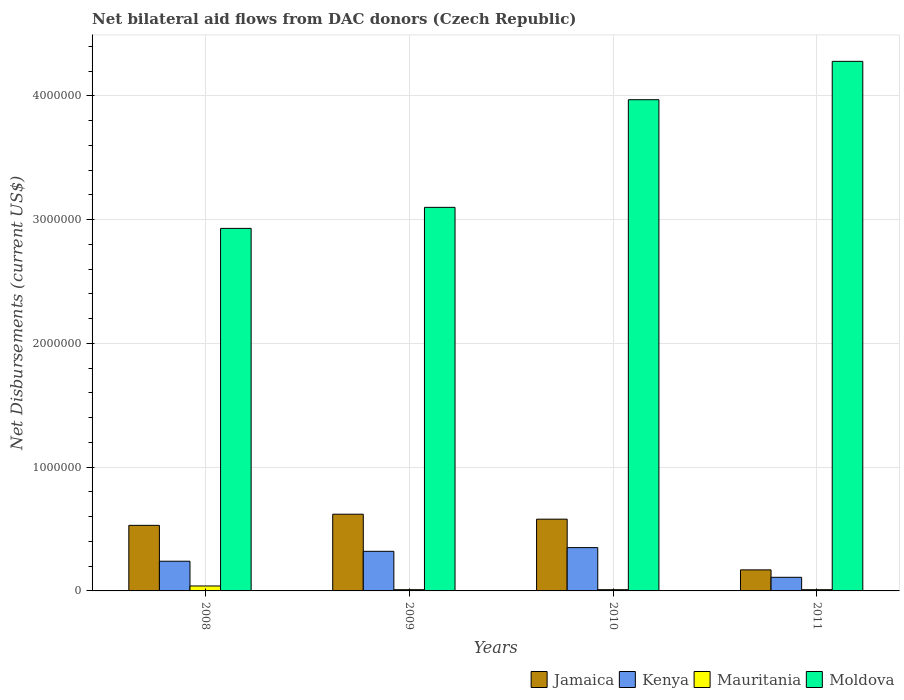How many groups of bars are there?
Provide a short and direct response. 4. Are the number of bars on each tick of the X-axis equal?
Your answer should be very brief. Yes. How many bars are there on the 2nd tick from the right?
Your answer should be compact. 4. What is the label of the 3rd group of bars from the left?
Ensure brevity in your answer.  2010. In how many cases, is the number of bars for a given year not equal to the number of legend labels?
Give a very brief answer. 0. What is the net bilateral aid flows in Moldova in 2009?
Ensure brevity in your answer.  3.10e+06. Across all years, what is the maximum net bilateral aid flows in Jamaica?
Make the answer very short. 6.20e+05. Across all years, what is the minimum net bilateral aid flows in Moldova?
Provide a succinct answer. 2.93e+06. What is the difference between the net bilateral aid flows in Kenya in 2009 and that in 2010?
Ensure brevity in your answer.  -3.00e+04. What is the difference between the net bilateral aid flows in Mauritania in 2011 and the net bilateral aid flows in Jamaica in 2010?
Keep it short and to the point. -5.70e+05. What is the average net bilateral aid flows in Moldova per year?
Your answer should be very brief. 3.57e+06. In the year 2008, what is the difference between the net bilateral aid flows in Mauritania and net bilateral aid flows in Moldova?
Your answer should be very brief. -2.89e+06. What is the ratio of the net bilateral aid flows in Kenya in 2010 to that in 2011?
Your response must be concise. 3.18. Is the difference between the net bilateral aid flows in Mauritania in 2008 and 2009 greater than the difference between the net bilateral aid flows in Moldova in 2008 and 2009?
Offer a very short reply. Yes. What is the difference between the highest and the second highest net bilateral aid flows in Mauritania?
Your answer should be very brief. 3.00e+04. Is it the case that in every year, the sum of the net bilateral aid flows in Kenya and net bilateral aid flows in Moldova is greater than the sum of net bilateral aid flows in Mauritania and net bilateral aid flows in Jamaica?
Your answer should be compact. No. What does the 4th bar from the left in 2011 represents?
Offer a terse response. Moldova. What does the 3rd bar from the right in 2011 represents?
Ensure brevity in your answer.  Kenya. Are all the bars in the graph horizontal?
Offer a very short reply. No. Does the graph contain grids?
Provide a short and direct response. Yes. Where does the legend appear in the graph?
Make the answer very short. Bottom right. How are the legend labels stacked?
Provide a short and direct response. Horizontal. What is the title of the graph?
Provide a short and direct response. Net bilateral aid flows from DAC donors (Czech Republic). What is the label or title of the Y-axis?
Provide a succinct answer. Net Disbursements (current US$). What is the Net Disbursements (current US$) of Jamaica in 2008?
Your answer should be compact. 5.30e+05. What is the Net Disbursements (current US$) of Moldova in 2008?
Give a very brief answer. 2.93e+06. What is the Net Disbursements (current US$) in Jamaica in 2009?
Your answer should be very brief. 6.20e+05. What is the Net Disbursements (current US$) of Kenya in 2009?
Give a very brief answer. 3.20e+05. What is the Net Disbursements (current US$) of Moldova in 2009?
Your answer should be very brief. 3.10e+06. What is the Net Disbursements (current US$) of Jamaica in 2010?
Your response must be concise. 5.80e+05. What is the Net Disbursements (current US$) of Moldova in 2010?
Give a very brief answer. 3.97e+06. What is the Net Disbursements (current US$) in Jamaica in 2011?
Offer a terse response. 1.70e+05. What is the Net Disbursements (current US$) in Mauritania in 2011?
Your answer should be very brief. 10000. What is the Net Disbursements (current US$) of Moldova in 2011?
Offer a terse response. 4.28e+06. Across all years, what is the maximum Net Disbursements (current US$) of Jamaica?
Give a very brief answer. 6.20e+05. Across all years, what is the maximum Net Disbursements (current US$) of Kenya?
Offer a very short reply. 3.50e+05. Across all years, what is the maximum Net Disbursements (current US$) of Mauritania?
Your response must be concise. 4.00e+04. Across all years, what is the maximum Net Disbursements (current US$) in Moldova?
Provide a succinct answer. 4.28e+06. Across all years, what is the minimum Net Disbursements (current US$) of Moldova?
Offer a very short reply. 2.93e+06. What is the total Net Disbursements (current US$) of Jamaica in the graph?
Your response must be concise. 1.90e+06. What is the total Net Disbursements (current US$) of Kenya in the graph?
Your response must be concise. 1.02e+06. What is the total Net Disbursements (current US$) in Moldova in the graph?
Keep it short and to the point. 1.43e+07. What is the difference between the Net Disbursements (current US$) of Kenya in 2008 and that in 2009?
Provide a short and direct response. -8.00e+04. What is the difference between the Net Disbursements (current US$) in Mauritania in 2008 and that in 2009?
Offer a terse response. 3.00e+04. What is the difference between the Net Disbursements (current US$) of Moldova in 2008 and that in 2009?
Your answer should be very brief. -1.70e+05. What is the difference between the Net Disbursements (current US$) of Jamaica in 2008 and that in 2010?
Offer a terse response. -5.00e+04. What is the difference between the Net Disbursements (current US$) of Kenya in 2008 and that in 2010?
Your answer should be very brief. -1.10e+05. What is the difference between the Net Disbursements (current US$) of Moldova in 2008 and that in 2010?
Provide a short and direct response. -1.04e+06. What is the difference between the Net Disbursements (current US$) in Jamaica in 2008 and that in 2011?
Give a very brief answer. 3.60e+05. What is the difference between the Net Disbursements (current US$) in Kenya in 2008 and that in 2011?
Ensure brevity in your answer.  1.30e+05. What is the difference between the Net Disbursements (current US$) of Mauritania in 2008 and that in 2011?
Your answer should be very brief. 3.00e+04. What is the difference between the Net Disbursements (current US$) in Moldova in 2008 and that in 2011?
Provide a short and direct response. -1.35e+06. What is the difference between the Net Disbursements (current US$) in Jamaica in 2009 and that in 2010?
Your answer should be compact. 4.00e+04. What is the difference between the Net Disbursements (current US$) in Kenya in 2009 and that in 2010?
Offer a very short reply. -3.00e+04. What is the difference between the Net Disbursements (current US$) in Mauritania in 2009 and that in 2010?
Offer a terse response. 0. What is the difference between the Net Disbursements (current US$) of Moldova in 2009 and that in 2010?
Keep it short and to the point. -8.70e+05. What is the difference between the Net Disbursements (current US$) of Kenya in 2009 and that in 2011?
Offer a terse response. 2.10e+05. What is the difference between the Net Disbursements (current US$) in Moldova in 2009 and that in 2011?
Your response must be concise. -1.18e+06. What is the difference between the Net Disbursements (current US$) in Kenya in 2010 and that in 2011?
Your answer should be compact. 2.40e+05. What is the difference between the Net Disbursements (current US$) in Mauritania in 2010 and that in 2011?
Provide a short and direct response. 0. What is the difference between the Net Disbursements (current US$) of Moldova in 2010 and that in 2011?
Offer a very short reply. -3.10e+05. What is the difference between the Net Disbursements (current US$) of Jamaica in 2008 and the Net Disbursements (current US$) of Kenya in 2009?
Make the answer very short. 2.10e+05. What is the difference between the Net Disbursements (current US$) of Jamaica in 2008 and the Net Disbursements (current US$) of Mauritania in 2009?
Your response must be concise. 5.20e+05. What is the difference between the Net Disbursements (current US$) of Jamaica in 2008 and the Net Disbursements (current US$) of Moldova in 2009?
Offer a terse response. -2.57e+06. What is the difference between the Net Disbursements (current US$) in Kenya in 2008 and the Net Disbursements (current US$) in Mauritania in 2009?
Make the answer very short. 2.30e+05. What is the difference between the Net Disbursements (current US$) in Kenya in 2008 and the Net Disbursements (current US$) in Moldova in 2009?
Your answer should be compact. -2.86e+06. What is the difference between the Net Disbursements (current US$) in Mauritania in 2008 and the Net Disbursements (current US$) in Moldova in 2009?
Ensure brevity in your answer.  -3.06e+06. What is the difference between the Net Disbursements (current US$) of Jamaica in 2008 and the Net Disbursements (current US$) of Mauritania in 2010?
Make the answer very short. 5.20e+05. What is the difference between the Net Disbursements (current US$) in Jamaica in 2008 and the Net Disbursements (current US$) in Moldova in 2010?
Keep it short and to the point. -3.44e+06. What is the difference between the Net Disbursements (current US$) of Kenya in 2008 and the Net Disbursements (current US$) of Mauritania in 2010?
Your response must be concise. 2.30e+05. What is the difference between the Net Disbursements (current US$) of Kenya in 2008 and the Net Disbursements (current US$) of Moldova in 2010?
Give a very brief answer. -3.73e+06. What is the difference between the Net Disbursements (current US$) of Mauritania in 2008 and the Net Disbursements (current US$) of Moldova in 2010?
Your response must be concise. -3.93e+06. What is the difference between the Net Disbursements (current US$) of Jamaica in 2008 and the Net Disbursements (current US$) of Mauritania in 2011?
Offer a terse response. 5.20e+05. What is the difference between the Net Disbursements (current US$) of Jamaica in 2008 and the Net Disbursements (current US$) of Moldova in 2011?
Your response must be concise. -3.75e+06. What is the difference between the Net Disbursements (current US$) of Kenya in 2008 and the Net Disbursements (current US$) of Moldova in 2011?
Your response must be concise. -4.04e+06. What is the difference between the Net Disbursements (current US$) of Mauritania in 2008 and the Net Disbursements (current US$) of Moldova in 2011?
Ensure brevity in your answer.  -4.24e+06. What is the difference between the Net Disbursements (current US$) in Jamaica in 2009 and the Net Disbursements (current US$) in Moldova in 2010?
Give a very brief answer. -3.35e+06. What is the difference between the Net Disbursements (current US$) in Kenya in 2009 and the Net Disbursements (current US$) in Mauritania in 2010?
Your answer should be compact. 3.10e+05. What is the difference between the Net Disbursements (current US$) in Kenya in 2009 and the Net Disbursements (current US$) in Moldova in 2010?
Your answer should be very brief. -3.65e+06. What is the difference between the Net Disbursements (current US$) in Mauritania in 2009 and the Net Disbursements (current US$) in Moldova in 2010?
Offer a terse response. -3.96e+06. What is the difference between the Net Disbursements (current US$) of Jamaica in 2009 and the Net Disbursements (current US$) of Kenya in 2011?
Your answer should be very brief. 5.10e+05. What is the difference between the Net Disbursements (current US$) of Jamaica in 2009 and the Net Disbursements (current US$) of Moldova in 2011?
Offer a very short reply. -3.66e+06. What is the difference between the Net Disbursements (current US$) in Kenya in 2009 and the Net Disbursements (current US$) in Moldova in 2011?
Offer a terse response. -3.96e+06. What is the difference between the Net Disbursements (current US$) of Mauritania in 2009 and the Net Disbursements (current US$) of Moldova in 2011?
Offer a terse response. -4.27e+06. What is the difference between the Net Disbursements (current US$) in Jamaica in 2010 and the Net Disbursements (current US$) in Kenya in 2011?
Provide a succinct answer. 4.70e+05. What is the difference between the Net Disbursements (current US$) of Jamaica in 2010 and the Net Disbursements (current US$) of Mauritania in 2011?
Make the answer very short. 5.70e+05. What is the difference between the Net Disbursements (current US$) of Jamaica in 2010 and the Net Disbursements (current US$) of Moldova in 2011?
Make the answer very short. -3.70e+06. What is the difference between the Net Disbursements (current US$) in Kenya in 2010 and the Net Disbursements (current US$) in Moldova in 2011?
Your answer should be compact. -3.93e+06. What is the difference between the Net Disbursements (current US$) in Mauritania in 2010 and the Net Disbursements (current US$) in Moldova in 2011?
Ensure brevity in your answer.  -4.27e+06. What is the average Net Disbursements (current US$) of Jamaica per year?
Keep it short and to the point. 4.75e+05. What is the average Net Disbursements (current US$) in Kenya per year?
Provide a succinct answer. 2.55e+05. What is the average Net Disbursements (current US$) in Mauritania per year?
Your response must be concise. 1.75e+04. What is the average Net Disbursements (current US$) in Moldova per year?
Provide a succinct answer. 3.57e+06. In the year 2008, what is the difference between the Net Disbursements (current US$) in Jamaica and Net Disbursements (current US$) in Moldova?
Your answer should be compact. -2.40e+06. In the year 2008, what is the difference between the Net Disbursements (current US$) of Kenya and Net Disbursements (current US$) of Moldova?
Your response must be concise. -2.69e+06. In the year 2008, what is the difference between the Net Disbursements (current US$) in Mauritania and Net Disbursements (current US$) in Moldova?
Ensure brevity in your answer.  -2.89e+06. In the year 2009, what is the difference between the Net Disbursements (current US$) in Jamaica and Net Disbursements (current US$) in Mauritania?
Ensure brevity in your answer.  6.10e+05. In the year 2009, what is the difference between the Net Disbursements (current US$) in Jamaica and Net Disbursements (current US$) in Moldova?
Give a very brief answer. -2.48e+06. In the year 2009, what is the difference between the Net Disbursements (current US$) of Kenya and Net Disbursements (current US$) of Mauritania?
Offer a very short reply. 3.10e+05. In the year 2009, what is the difference between the Net Disbursements (current US$) of Kenya and Net Disbursements (current US$) of Moldova?
Keep it short and to the point. -2.78e+06. In the year 2009, what is the difference between the Net Disbursements (current US$) in Mauritania and Net Disbursements (current US$) in Moldova?
Give a very brief answer. -3.09e+06. In the year 2010, what is the difference between the Net Disbursements (current US$) in Jamaica and Net Disbursements (current US$) in Kenya?
Provide a succinct answer. 2.30e+05. In the year 2010, what is the difference between the Net Disbursements (current US$) in Jamaica and Net Disbursements (current US$) in Mauritania?
Give a very brief answer. 5.70e+05. In the year 2010, what is the difference between the Net Disbursements (current US$) of Jamaica and Net Disbursements (current US$) of Moldova?
Offer a terse response. -3.39e+06. In the year 2010, what is the difference between the Net Disbursements (current US$) in Kenya and Net Disbursements (current US$) in Moldova?
Your answer should be very brief. -3.62e+06. In the year 2010, what is the difference between the Net Disbursements (current US$) in Mauritania and Net Disbursements (current US$) in Moldova?
Your response must be concise. -3.96e+06. In the year 2011, what is the difference between the Net Disbursements (current US$) in Jamaica and Net Disbursements (current US$) in Moldova?
Offer a terse response. -4.11e+06. In the year 2011, what is the difference between the Net Disbursements (current US$) of Kenya and Net Disbursements (current US$) of Moldova?
Provide a short and direct response. -4.17e+06. In the year 2011, what is the difference between the Net Disbursements (current US$) of Mauritania and Net Disbursements (current US$) of Moldova?
Offer a very short reply. -4.27e+06. What is the ratio of the Net Disbursements (current US$) in Jamaica in 2008 to that in 2009?
Your answer should be compact. 0.85. What is the ratio of the Net Disbursements (current US$) in Kenya in 2008 to that in 2009?
Your answer should be very brief. 0.75. What is the ratio of the Net Disbursements (current US$) of Mauritania in 2008 to that in 2009?
Provide a succinct answer. 4. What is the ratio of the Net Disbursements (current US$) in Moldova in 2008 to that in 2009?
Your answer should be very brief. 0.95. What is the ratio of the Net Disbursements (current US$) in Jamaica in 2008 to that in 2010?
Keep it short and to the point. 0.91. What is the ratio of the Net Disbursements (current US$) in Kenya in 2008 to that in 2010?
Offer a very short reply. 0.69. What is the ratio of the Net Disbursements (current US$) in Moldova in 2008 to that in 2010?
Your answer should be compact. 0.74. What is the ratio of the Net Disbursements (current US$) of Jamaica in 2008 to that in 2011?
Keep it short and to the point. 3.12. What is the ratio of the Net Disbursements (current US$) of Kenya in 2008 to that in 2011?
Ensure brevity in your answer.  2.18. What is the ratio of the Net Disbursements (current US$) of Mauritania in 2008 to that in 2011?
Give a very brief answer. 4. What is the ratio of the Net Disbursements (current US$) of Moldova in 2008 to that in 2011?
Offer a very short reply. 0.68. What is the ratio of the Net Disbursements (current US$) of Jamaica in 2009 to that in 2010?
Provide a short and direct response. 1.07. What is the ratio of the Net Disbursements (current US$) of Kenya in 2009 to that in 2010?
Your response must be concise. 0.91. What is the ratio of the Net Disbursements (current US$) in Moldova in 2009 to that in 2010?
Offer a terse response. 0.78. What is the ratio of the Net Disbursements (current US$) of Jamaica in 2009 to that in 2011?
Make the answer very short. 3.65. What is the ratio of the Net Disbursements (current US$) in Kenya in 2009 to that in 2011?
Keep it short and to the point. 2.91. What is the ratio of the Net Disbursements (current US$) of Moldova in 2009 to that in 2011?
Your response must be concise. 0.72. What is the ratio of the Net Disbursements (current US$) of Jamaica in 2010 to that in 2011?
Provide a succinct answer. 3.41. What is the ratio of the Net Disbursements (current US$) of Kenya in 2010 to that in 2011?
Make the answer very short. 3.18. What is the ratio of the Net Disbursements (current US$) of Moldova in 2010 to that in 2011?
Provide a succinct answer. 0.93. What is the difference between the highest and the second highest Net Disbursements (current US$) in Jamaica?
Offer a terse response. 4.00e+04. What is the difference between the highest and the lowest Net Disbursements (current US$) of Moldova?
Make the answer very short. 1.35e+06. 